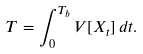<formula> <loc_0><loc_0><loc_500><loc_500>T = \int _ { 0 } ^ { T _ { b } } V [ X _ { t } ] \, d t .</formula> 